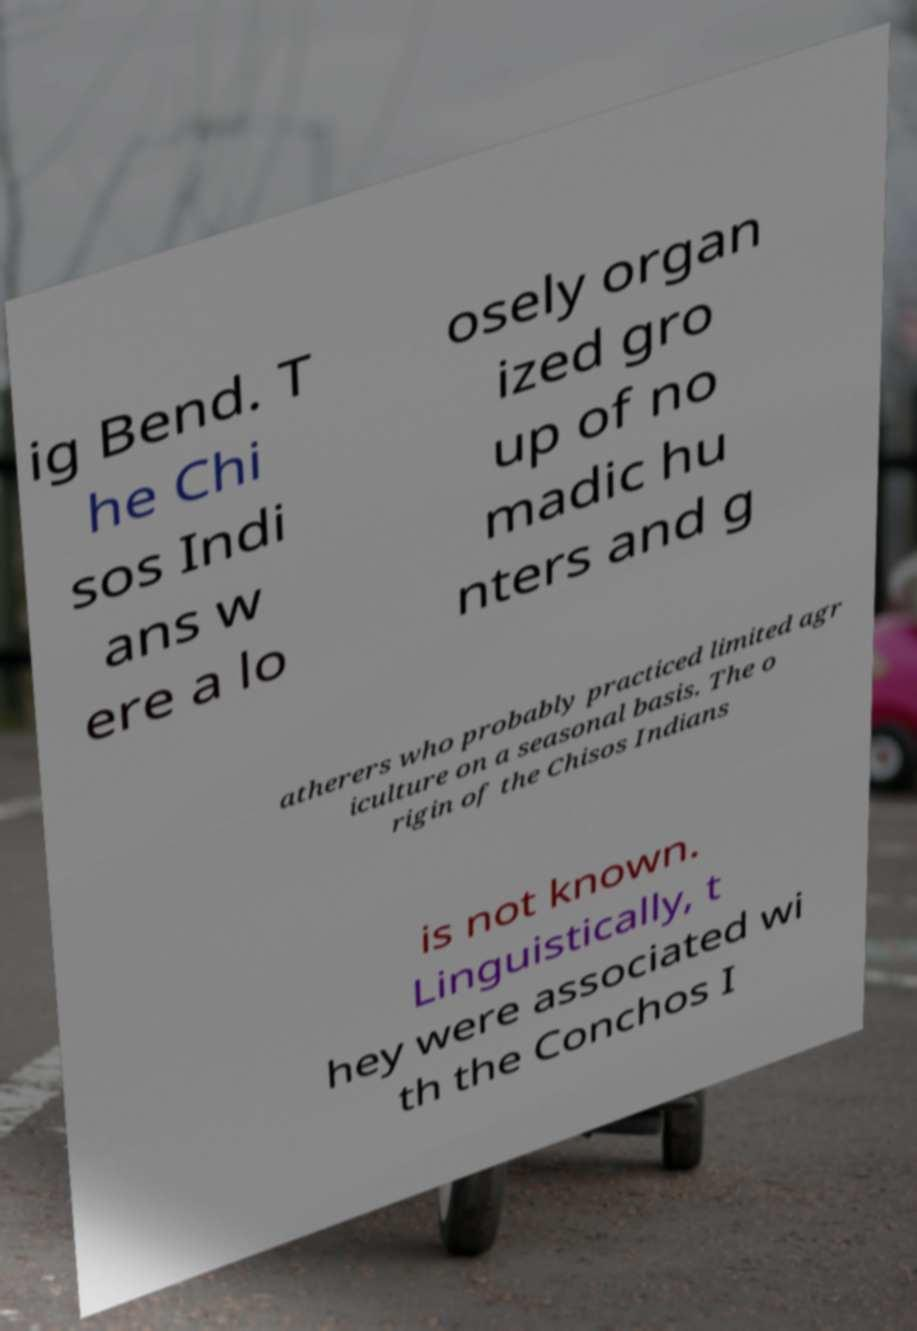Can you read and provide the text displayed in the image?This photo seems to have some interesting text. Can you extract and type it out for me? ig Bend. T he Chi sos Indi ans w ere a lo osely organ ized gro up of no madic hu nters and g atherers who probably practiced limited agr iculture on a seasonal basis. The o rigin of the Chisos Indians is not known. Linguistically, t hey were associated wi th the Conchos I 